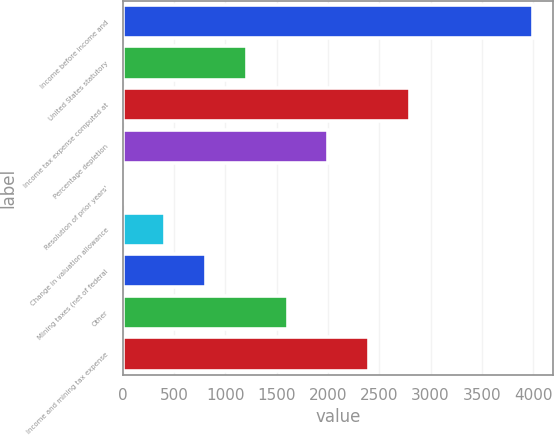Convert chart to OTSL. <chart><loc_0><loc_0><loc_500><loc_500><bar_chart><fcel>Income before income and<fcel>United States statutory<fcel>Income tax expense computed at<fcel>Percentage depletion<fcel>Resolution of prior years'<fcel>Change in valuation allowance<fcel>Mining taxes (net of federal<fcel>Other<fcel>Income and mining tax expense<nl><fcel>3997<fcel>1206.8<fcel>2801.2<fcel>2004<fcel>11<fcel>409.6<fcel>808.2<fcel>1605.4<fcel>2402.6<nl></chart> 